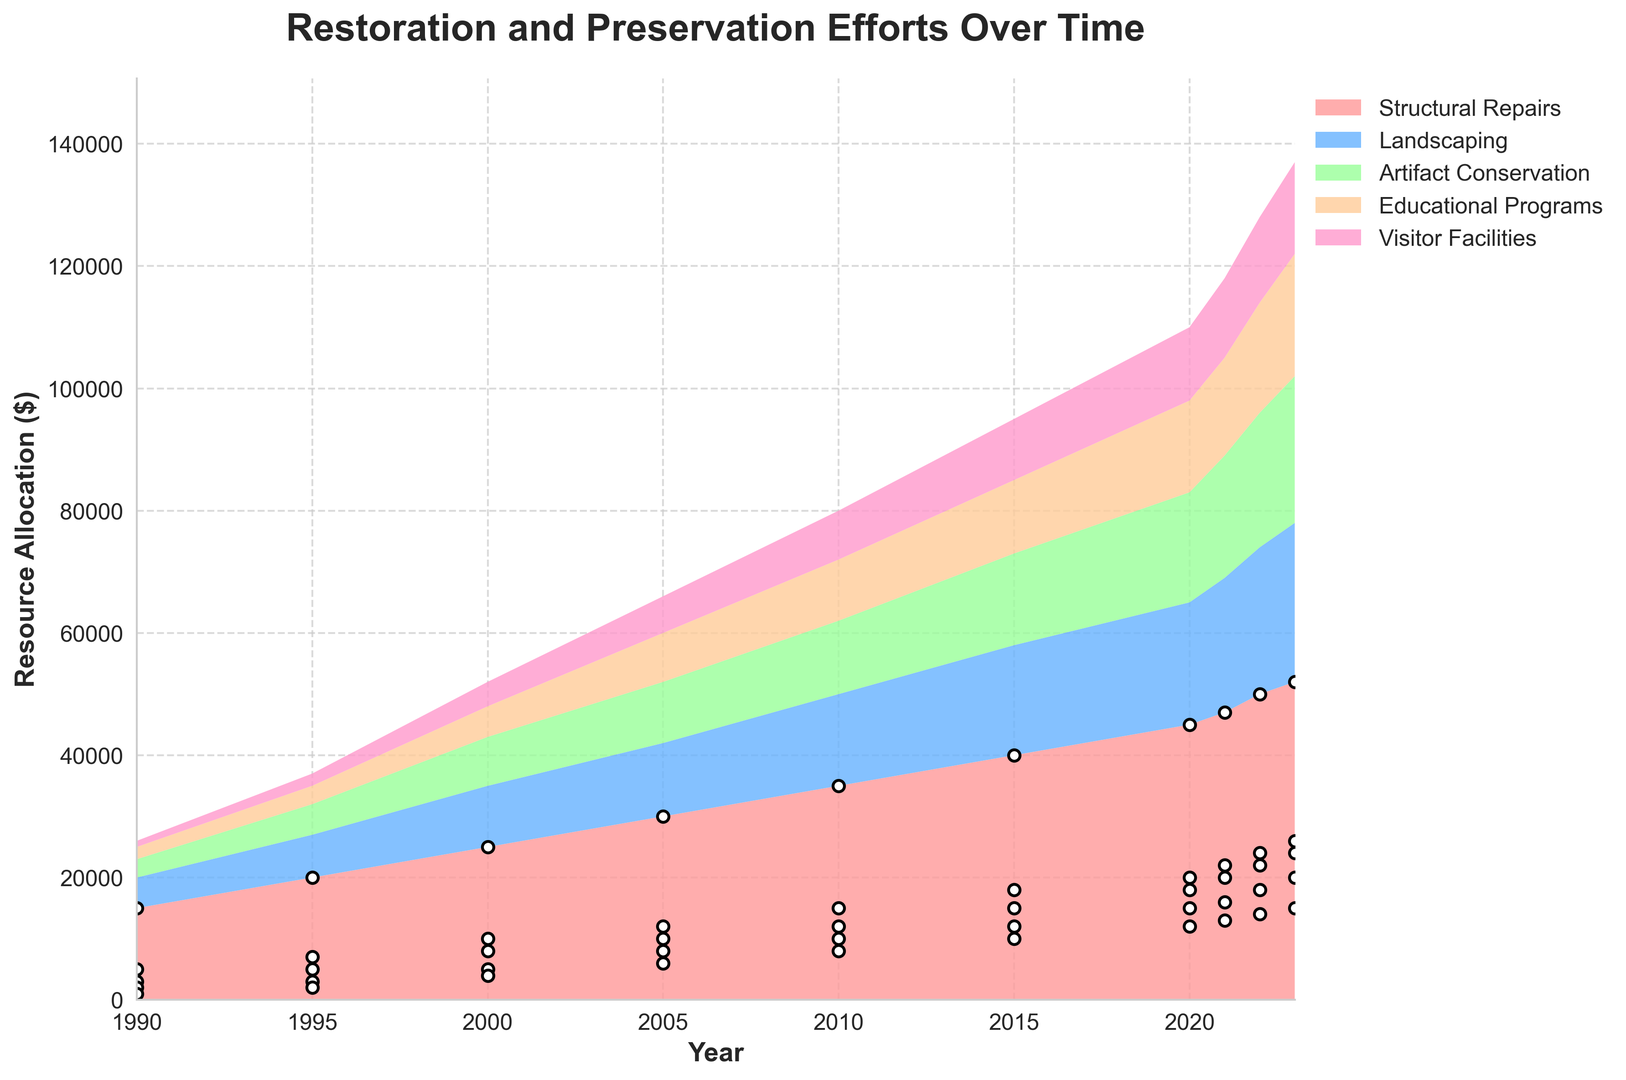What is the overall trend in the allocation of resources for Visitor Facilities from 1990 to 2023? The allocation for Visitor Facilities shows a clear increasing trend. Starting from $1,000 in 1990, it steadily rises to $15,000 by 2023. Even though the growth is smoother initially and becomes more significant after 2000, the overall trend is upward.
Answer: Increasing trend Which area received the highest increase in allocated resources from 1990 to 2023? To determine the area with the highest increase, subtract the 1990 allocation from the 2023 allocation for each category: Structural Repairs (52,000 - 15,000 = 37,000), Landscaping (26,000 - 5,000 = 21,000), Artifact Conservation (24,000 - 3,000 = 21,000), Educational Programs (20,000 - 2,000 = 18,000), and Visitor Facilities (15,000 - 1,000 = 14,000). Structural Repairs exhibit the highest increase.
Answer: Structural Repairs How did the resource allocation for Landscaping and Visitor Facilities compare in 2020? In 2020, Landscaping received $20,000 and Visitor Facilities received $12,000 in resources. Landscaping received more resources than Visitor Facilities in that year.
Answer: Landscaping received more What is the average annual allocation for Artifact Conservation from 1990 to 2023? Sum the allocations for Artifact Conservation over the years (3,000 + 5,000 + 8,000 + 10,000 + 12,000 + 15,000 + 18,000 + 20,000 + 22,000 + 24,000) = 137,000, then divide by the number of years (2023 - 1990 + 1 = 34). The average is 137,000 / 34 ≈ 4,029.41.
Answer: Approximately $4,029.41 By how much did the allocation for Educational Programs change between 1995 and 2015? Subtract the 1995 allocation for Educational Programs from the 2015 allocation: 12,000 - 3,000 = 9,000. The allocation increased by $9,000 between these years.
Answer: Increased by $9,000 Among all the areas, which one remained relatively low in its allocation throughout the years? Comparing the overall trends, Visitor Facilities consistently receive lower allocation amounts compared to other areas. Even in 2023, its allocation is $15,000, which is lower than most other categories.
Answer: Visitor Facilities In which years did the resource allocation for Structural Repairs change by exactly $5,000 from the previous year? To identify these years, look at the yearly allocations for Structural Repairs and identify where the difference is $5,000: 1995 (20,000 - 15,000), 2000 (25,000 - 20,000), 2005 (30,000 - 25,000), 2010 (35,000 - 30,000), and 2015 (40,000 - 35,000). Thus, the relevant years are 1995, 2000, 2005, 2010, and 2015.
Answer: 1995, 2000, 2005, 2010, 2015 